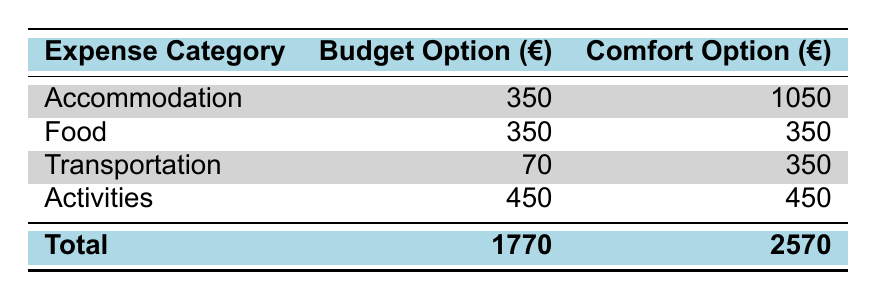What is the total accommodation cost for the hotel? The total accommodation cost for the hotel is provided in the table under the accommodation category, specifically noted as 1050 euros.
Answer: 1050 What is the food cost for a week in Finland? The total food cost for a week is listed in the table. Since both budget and comfort options have the same food cost, the answer is simply 350 euros.
Answer: 350 What is the difference in total costs between the hotel option and the hostel option? To find the difference, subtract the total cost for the hostel (1770 euros) from the total cost for the hotel (2570 euros): 2570 - 1770 = 800 euros.
Answer: 800 Is the cost for activities the same for both accommodation options? Yes, the cost for activities is 450 euros for both the budget and comfort accommodation options, which means the statement is true.
Answer: Yes How much would a traveler save by choosing the hostel over the hotel for their stay? The cost for the hotel is 2570 euros and for the hostel is 1770 euros. To find the savings, subtract the hostel cost from the hotel cost: 2570 - 1770 = 800 euros saved by choosing the hostel.
Answer: 800 What is the total estimated cost including accommodation, food, transportation, and activities for both options? The total estimated cost for the hotel option is 2570 euros and for the hostel option is 1770 euros, as summarized in the total line of the table.
Answer: Hotel: 2570, Hostel: 1770 Is public transportation cheaper than car rental for the week? Public transportation costs 70 euros for the week, while car rental costs 350 euros. Since 70 is less than 350, public transportation is indeed cheaper.
Answer: Yes What is the total estimated cost for meals per week? The total estimated meal costs can be calculated by summing the individual meal costs: breakfast (70 euros) + lunch (105 euros) + dinner (175 euros) = 350 euros total for meals.
Answer: 350 How much is the average cost of an activity in the activities section? The average cost of an activity is listed in the table as 30 euros per activity.
Answer: 30 